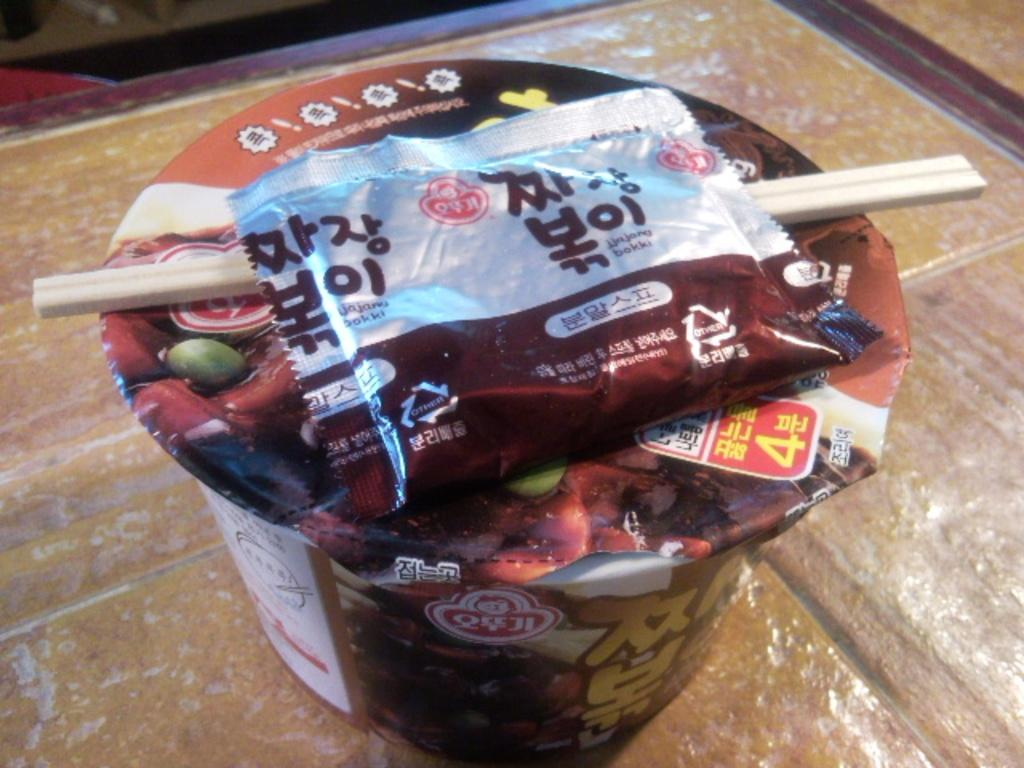What is the food item contained in? The food item is in a cup. What is the color of the cup? The cup is brown in color. How many ladybugs hands are holding the brown cup in the image? There is no mention of hands or a lady in the provided facts, and the image does not show any hands or a lady holding the cup. 